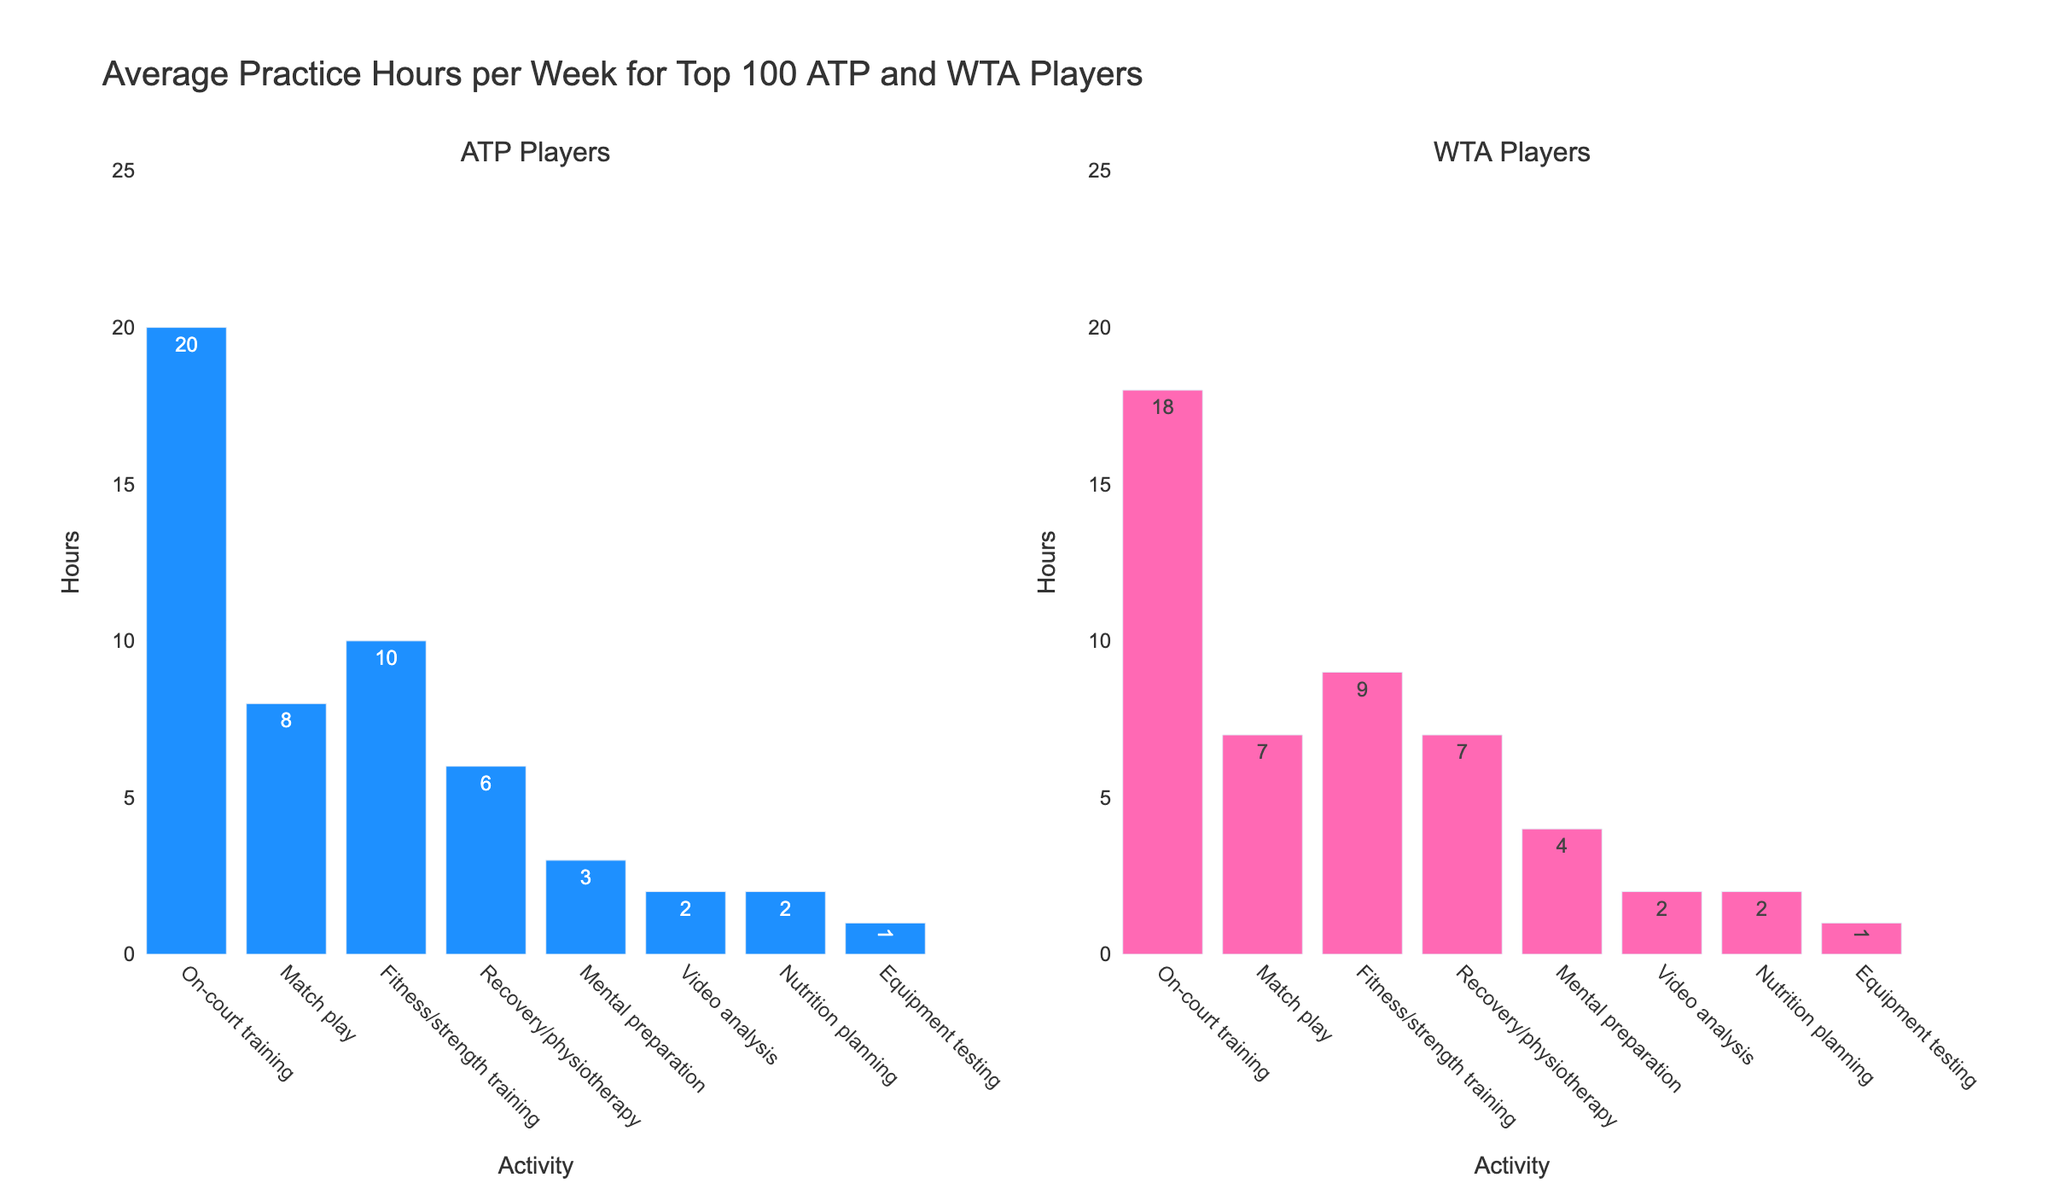How many more hours do ATP players spend on fitness/strength training compared to WTA players? ATP players spend 10 hours on fitness/strength training and WTA players spend 9 hours. The difference is 10 - 9 = 1 hour.
Answer: 1 hour Who spends more time on on-court training, ATP or WTA players? By how much? ATP players spend 20 hours on on-court training while WTA players spend 18 hours. The difference is 20 - 18 = 2 hours.
Answer: ATP by 2 hours Which activity do both ATP and WTA players spend the least amount of time on? By looking at the bar heights, equipment testing has the shortest bars for both ATP and WTA players, indicating the least time spent.
Answer: Equipment testing What is the combined total of hours spent by WTA players on match play and recovery/physiotherapy? WTA players spend 7 hours on match play and 7 hours on recovery/physiotherapy. Adding them gives 7 + 7 = 14 hours.
Answer: 14 hours Comparing mental preparation time, who spends more, ATP or WTA players? ATP players spend 3 hours on mental preparation, whereas WTA players spend 4 hours. Comparing the two, 4 hours is greater.
Answer: WTA players How much total time do ATP players spend on video analysis and nutrition planning? ATP players spend 2 hours on video analysis and 2 hours on nutrition planning. The total is 2 + 2 = 4 hours.
Answer: 4 hours Which group spends more total time on non-court activities (excluding on-court training and match play)? For ATP players: Fitness (10) + Recovery (6) + Mental (3) + Video (2) + Nutrition (2) + Equipment (1) = 24 hours. For WTA players: Fitness (9) + Recovery (7) + Mental (4) + Video (2) + Nutrition (2) + Equipment (1) = 25 hours. WTA spends 25 - 24 = 1 hour more.
Answer: WTA players What is the ratio of hours spent on match play to on-court training for ATP players? ATP players spend 8 hours on match play and 20 hours on on-court training. The ratio is 8:20, which simplifies to 2:5.
Answer: 2:5 Which activity shows the smallest difference in practice hours between ATP and WTA players? Based on the bar heights, video analysis and nutrition planning both have the same values (2 hours each). Thus, the difference is 0 in both cases.
Answer: Video analysis and nutrition planning 